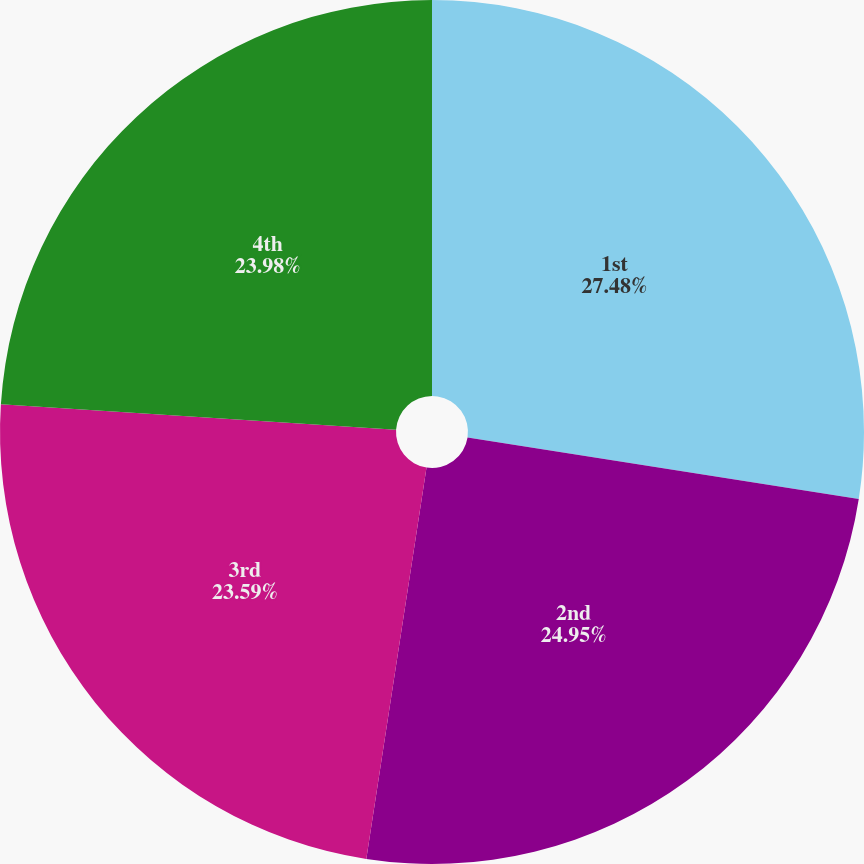Convert chart. <chart><loc_0><loc_0><loc_500><loc_500><pie_chart><fcel>1st<fcel>2nd<fcel>3rd<fcel>4th<nl><fcel>27.48%<fcel>24.95%<fcel>23.59%<fcel>23.98%<nl></chart> 